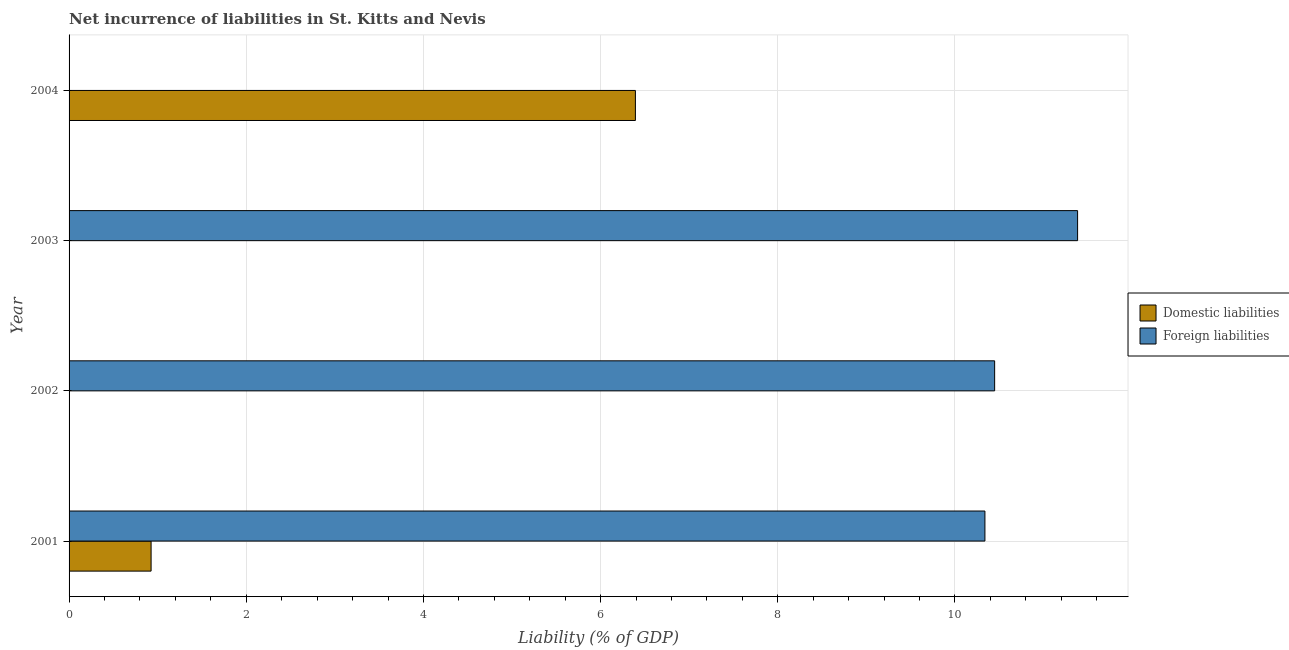How many different coloured bars are there?
Offer a very short reply. 2. Are the number of bars per tick equal to the number of legend labels?
Offer a terse response. No. What is the label of the 1st group of bars from the top?
Offer a terse response. 2004. Across all years, what is the maximum incurrence of foreign liabilities?
Ensure brevity in your answer.  11.38. Across all years, what is the minimum incurrence of domestic liabilities?
Provide a short and direct response. 0. In which year was the incurrence of domestic liabilities maximum?
Your response must be concise. 2004. What is the total incurrence of domestic liabilities in the graph?
Offer a terse response. 7.32. What is the difference between the incurrence of foreign liabilities in 2001 and that in 2002?
Your answer should be very brief. -0.11. What is the difference between the incurrence of foreign liabilities in 2004 and the incurrence of domestic liabilities in 2001?
Give a very brief answer. -0.93. What is the average incurrence of foreign liabilities per year?
Provide a short and direct response. 8.04. In the year 2001, what is the difference between the incurrence of foreign liabilities and incurrence of domestic liabilities?
Offer a very short reply. 9.41. In how many years, is the incurrence of foreign liabilities greater than 10.4 %?
Offer a very short reply. 2. What is the difference between the highest and the second highest incurrence of foreign liabilities?
Your answer should be compact. 0.94. What is the difference between the highest and the lowest incurrence of foreign liabilities?
Provide a succinct answer. 11.38. In how many years, is the incurrence of domestic liabilities greater than the average incurrence of domestic liabilities taken over all years?
Provide a succinct answer. 1. Is the sum of the incurrence of foreign liabilities in 2001 and 2003 greater than the maximum incurrence of domestic liabilities across all years?
Provide a short and direct response. Yes. How many bars are there?
Your answer should be very brief. 5. What is the difference between two consecutive major ticks on the X-axis?
Give a very brief answer. 2. Are the values on the major ticks of X-axis written in scientific E-notation?
Provide a short and direct response. No. Where does the legend appear in the graph?
Keep it short and to the point. Center right. How many legend labels are there?
Give a very brief answer. 2. What is the title of the graph?
Keep it short and to the point. Net incurrence of liabilities in St. Kitts and Nevis. Does "Arms exports" appear as one of the legend labels in the graph?
Your answer should be very brief. No. What is the label or title of the X-axis?
Your answer should be very brief. Liability (% of GDP). What is the label or title of the Y-axis?
Your response must be concise. Year. What is the Liability (% of GDP) of Domestic liabilities in 2001?
Provide a short and direct response. 0.93. What is the Liability (% of GDP) in Foreign liabilities in 2001?
Make the answer very short. 10.34. What is the Liability (% of GDP) in Foreign liabilities in 2002?
Give a very brief answer. 10.45. What is the Liability (% of GDP) of Domestic liabilities in 2003?
Provide a short and direct response. 0. What is the Liability (% of GDP) in Foreign liabilities in 2003?
Offer a terse response. 11.38. What is the Liability (% of GDP) in Domestic liabilities in 2004?
Keep it short and to the point. 6.39. What is the Liability (% of GDP) in Foreign liabilities in 2004?
Provide a succinct answer. 0. Across all years, what is the maximum Liability (% of GDP) of Domestic liabilities?
Provide a succinct answer. 6.39. Across all years, what is the maximum Liability (% of GDP) in Foreign liabilities?
Your answer should be compact. 11.38. Across all years, what is the minimum Liability (% of GDP) of Domestic liabilities?
Give a very brief answer. 0. Across all years, what is the minimum Liability (% of GDP) in Foreign liabilities?
Provide a short and direct response. 0. What is the total Liability (% of GDP) of Domestic liabilities in the graph?
Your answer should be compact. 7.32. What is the total Liability (% of GDP) of Foreign liabilities in the graph?
Provide a succinct answer. 32.17. What is the difference between the Liability (% of GDP) of Foreign liabilities in 2001 and that in 2002?
Make the answer very short. -0.11. What is the difference between the Liability (% of GDP) in Foreign liabilities in 2001 and that in 2003?
Your answer should be very brief. -1.05. What is the difference between the Liability (% of GDP) of Domestic liabilities in 2001 and that in 2004?
Keep it short and to the point. -5.47. What is the difference between the Liability (% of GDP) in Foreign liabilities in 2002 and that in 2003?
Offer a very short reply. -0.94. What is the difference between the Liability (% of GDP) of Domestic liabilities in 2001 and the Liability (% of GDP) of Foreign liabilities in 2002?
Offer a very short reply. -9.52. What is the difference between the Liability (% of GDP) in Domestic liabilities in 2001 and the Liability (% of GDP) in Foreign liabilities in 2003?
Keep it short and to the point. -10.46. What is the average Liability (% of GDP) in Domestic liabilities per year?
Your response must be concise. 1.83. What is the average Liability (% of GDP) in Foreign liabilities per year?
Your answer should be very brief. 8.04. In the year 2001, what is the difference between the Liability (% of GDP) of Domestic liabilities and Liability (% of GDP) of Foreign liabilities?
Ensure brevity in your answer.  -9.41. What is the ratio of the Liability (% of GDP) in Foreign liabilities in 2001 to that in 2003?
Offer a very short reply. 0.91. What is the ratio of the Liability (% of GDP) of Domestic liabilities in 2001 to that in 2004?
Your answer should be compact. 0.14. What is the ratio of the Liability (% of GDP) of Foreign liabilities in 2002 to that in 2003?
Offer a terse response. 0.92. What is the difference between the highest and the second highest Liability (% of GDP) in Foreign liabilities?
Offer a very short reply. 0.94. What is the difference between the highest and the lowest Liability (% of GDP) of Domestic liabilities?
Your answer should be very brief. 6.39. What is the difference between the highest and the lowest Liability (% of GDP) in Foreign liabilities?
Your answer should be compact. 11.38. 